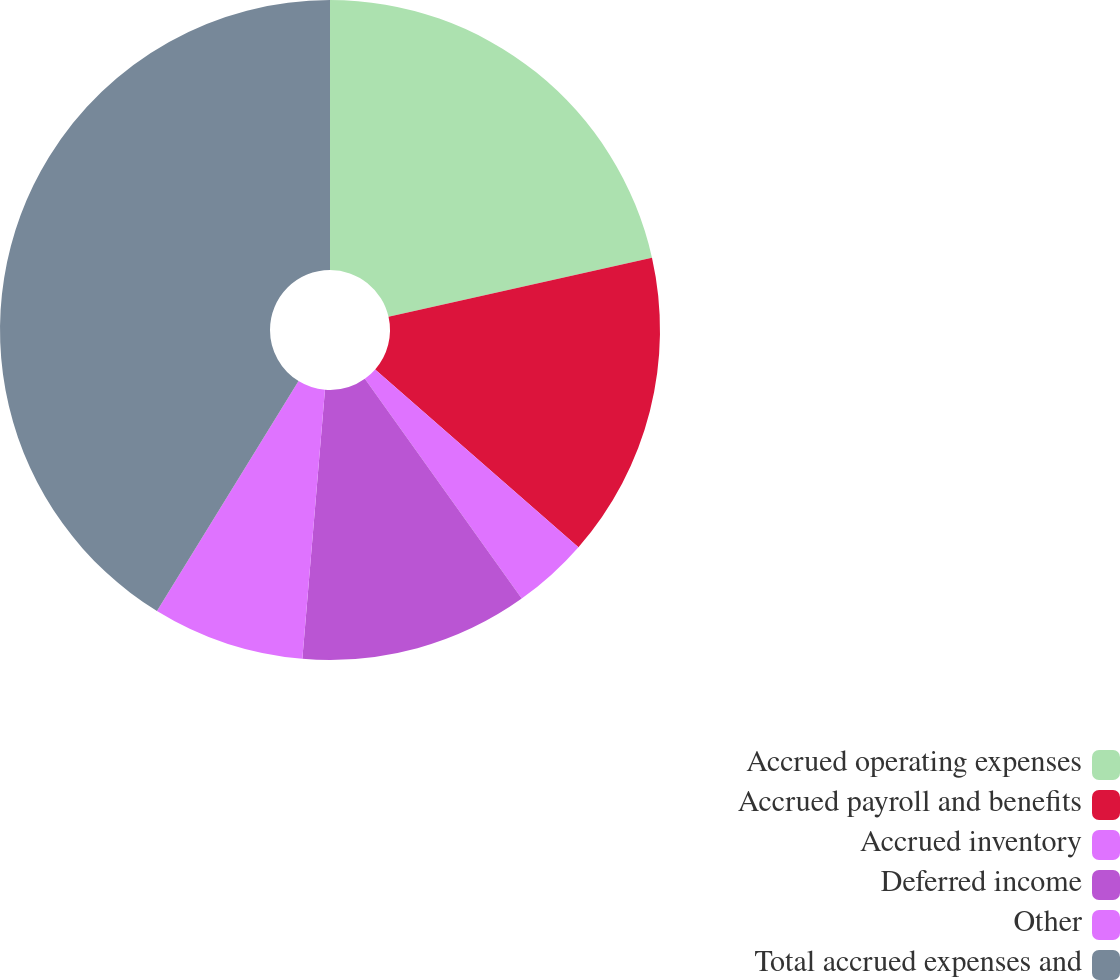Convert chart to OTSL. <chart><loc_0><loc_0><loc_500><loc_500><pie_chart><fcel>Accrued operating expenses<fcel>Accrued payroll and benefits<fcel>Accrued inventory<fcel>Deferred income<fcel>Other<fcel>Total accrued expenses and<nl><fcel>21.48%<fcel>14.95%<fcel>3.7%<fcel>11.2%<fcel>7.45%<fcel>41.21%<nl></chart> 